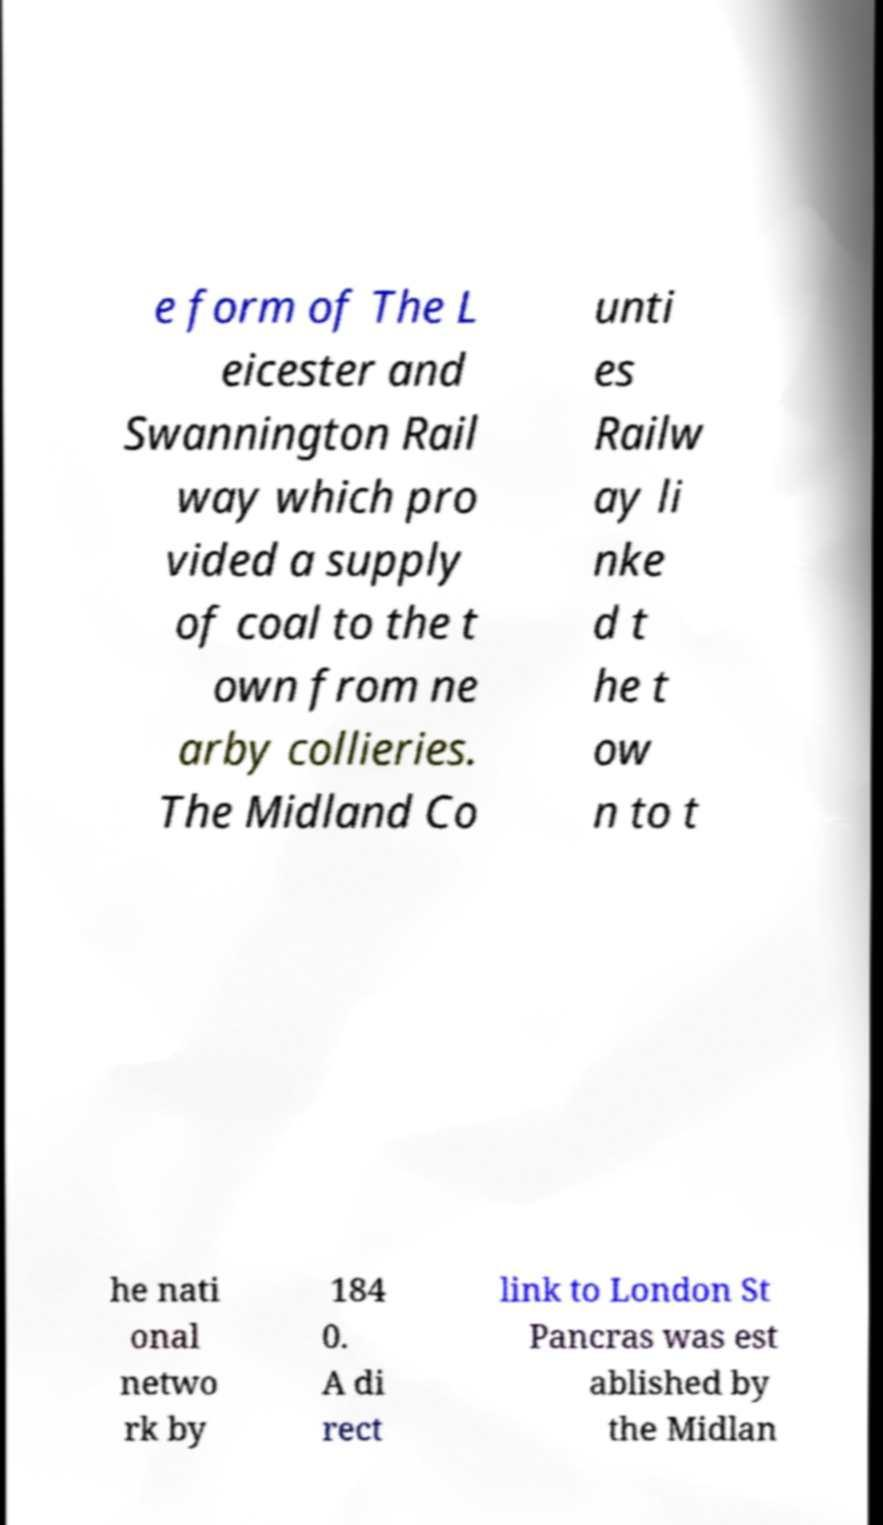Could you extract and type out the text from this image? e form of The L eicester and Swannington Rail way which pro vided a supply of coal to the t own from ne arby collieries. The Midland Co unti es Railw ay li nke d t he t ow n to t he nati onal netwo rk by 184 0. A di rect link to London St Pancras was est ablished by the Midlan 